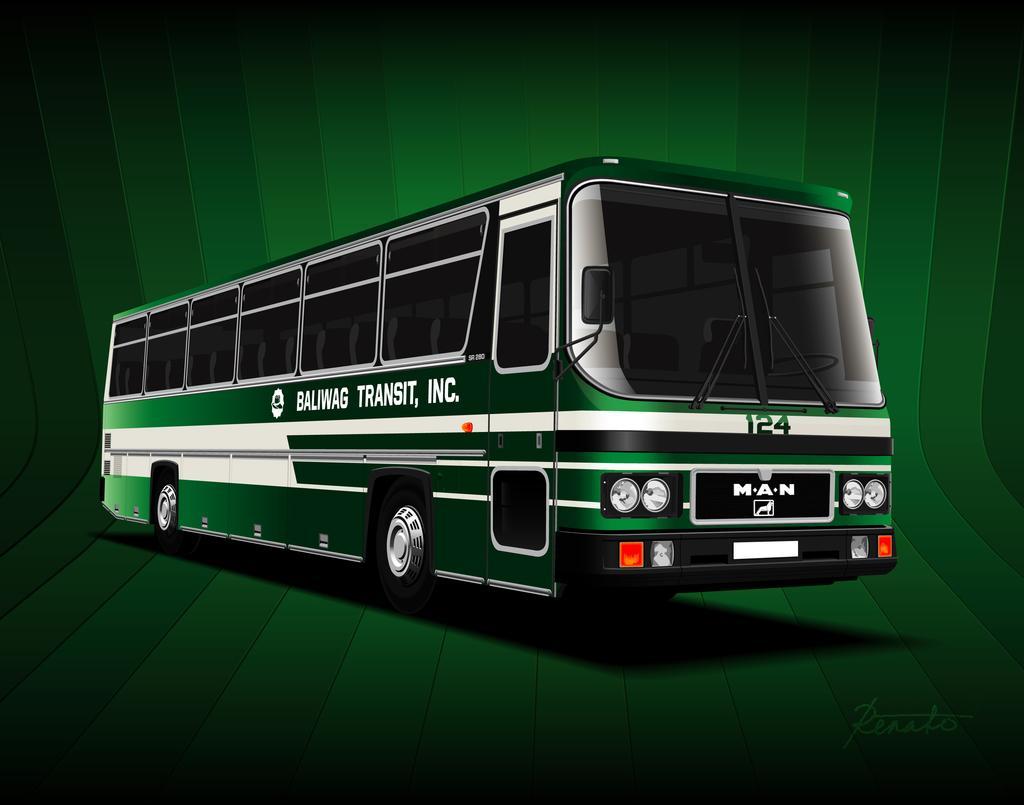Describe this image in one or two sentences. This is a graphical image of a bus and I can see green color background and a watermark at the bottom right corner of the picture. 